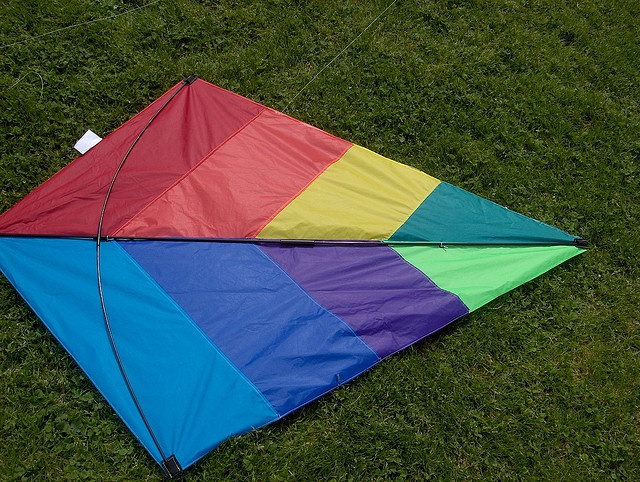Describe the objects in this image and their specific colors. I can see a kite in darkgreen, blue, teal, and salmon tones in this image. 